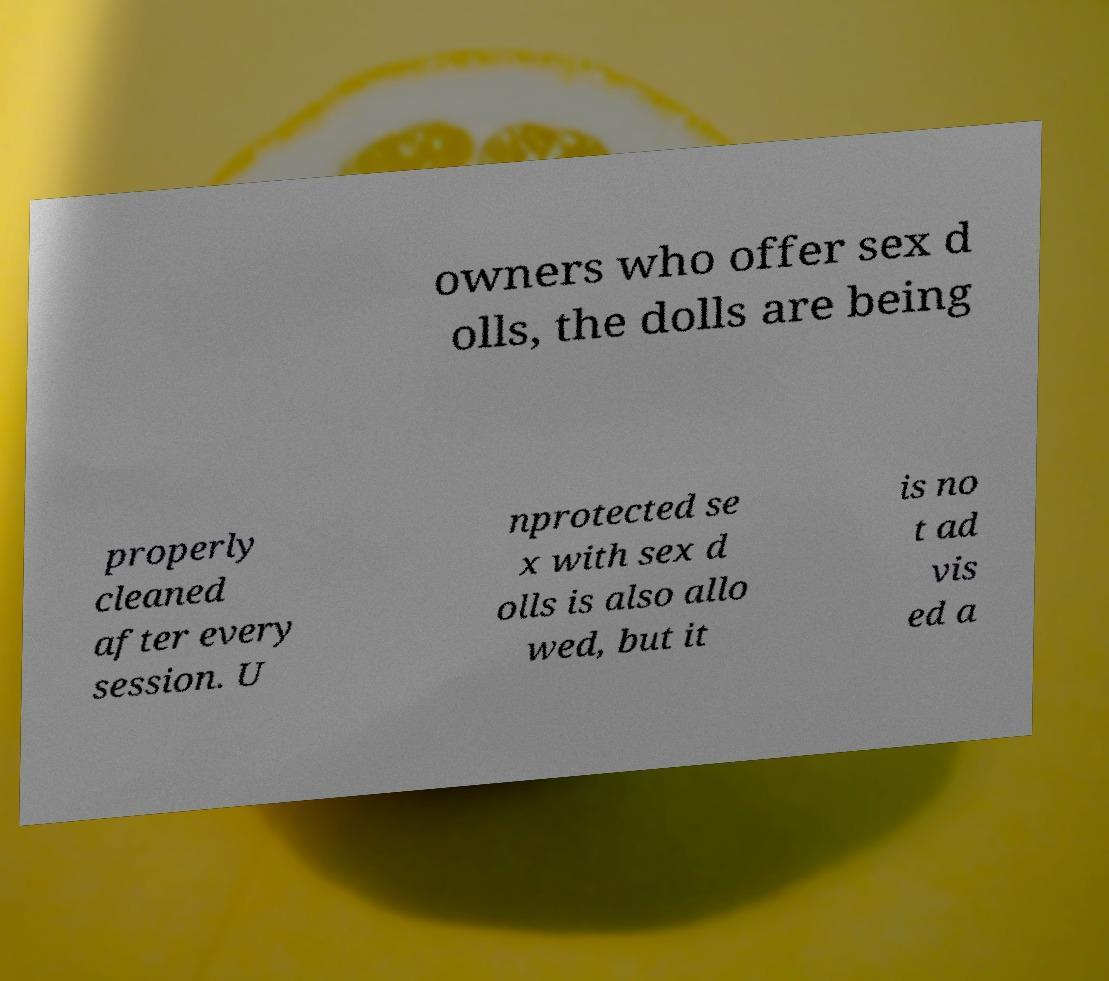Please identify and transcribe the text found in this image. owners who offer sex d olls, the dolls are being properly cleaned after every session. U nprotected se x with sex d olls is also allo wed, but it is no t ad vis ed a 